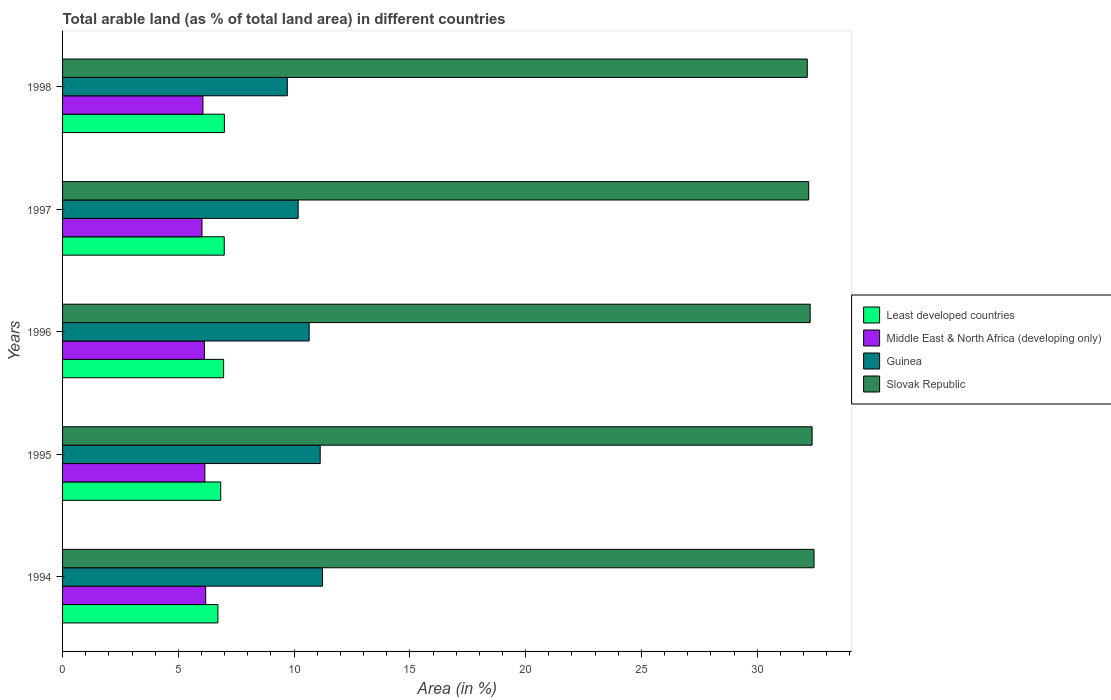How many different coloured bars are there?
Your answer should be compact. 4. Are the number of bars per tick equal to the number of legend labels?
Keep it short and to the point. Yes. How many bars are there on the 2nd tick from the top?
Offer a terse response. 4. How many bars are there on the 4th tick from the bottom?
Make the answer very short. 4. In how many cases, is the number of bars for a given year not equal to the number of legend labels?
Offer a terse response. 0. What is the percentage of arable land in Middle East & North Africa (developing only) in 1994?
Give a very brief answer. 6.18. Across all years, what is the maximum percentage of arable land in Slovak Republic?
Make the answer very short. 32.45. Across all years, what is the minimum percentage of arable land in Slovak Republic?
Ensure brevity in your answer.  32.16. What is the total percentage of arable land in Slovak Republic in the graph?
Offer a terse response. 161.5. What is the difference between the percentage of arable land in Slovak Republic in 1996 and that in 1998?
Keep it short and to the point. 0.12. What is the difference between the percentage of arable land in Least developed countries in 1994 and the percentage of arable land in Slovak Republic in 1998?
Offer a terse response. -25.45. What is the average percentage of arable land in Least developed countries per year?
Provide a succinct answer. 6.89. In the year 1997, what is the difference between the percentage of arable land in Guinea and percentage of arable land in Slovak Republic?
Offer a very short reply. -22.05. What is the ratio of the percentage of arable land in Guinea in 1996 to that in 1997?
Provide a short and direct response. 1.05. What is the difference between the highest and the second highest percentage of arable land in Least developed countries?
Provide a short and direct response. 0.01. What is the difference between the highest and the lowest percentage of arable land in Guinea?
Ensure brevity in your answer.  1.52. In how many years, is the percentage of arable land in Guinea greater than the average percentage of arable land in Guinea taken over all years?
Offer a very short reply. 3. What does the 3rd bar from the top in 1995 represents?
Provide a short and direct response. Middle East & North Africa (developing only). What does the 2nd bar from the bottom in 1996 represents?
Your answer should be very brief. Middle East & North Africa (developing only). How many bars are there?
Keep it short and to the point. 20. Does the graph contain any zero values?
Provide a succinct answer. No. Where does the legend appear in the graph?
Your answer should be compact. Center right. What is the title of the graph?
Offer a very short reply. Total arable land (as % of total land area) in different countries. Does "Sudan" appear as one of the legend labels in the graph?
Your answer should be compact. No. What is the label or title of the X-axis?
Offer a terse response. Area (in %). What is the Area (in %) of Least developed countries in 1994?
Give a very brief answer. 6.71. What is the Area (in %) of Middle East & North Africa (developing only) in 1994?
Provide a succinct answer. 6.18. What is the Area (in %) in Guinea in 1994?
Your response must be concise. 11.22. What is the Area (in %) of Slovak Republic in 1994?
Provide a short and direct response. 32.45. What is the Area (in %) of Least developed countries in 1995?
Offer a very short reply. 6.83. What is the Area (in %) of Middle East & North Africa (developing only) in 1995?
Give a very brief answer. 6.15. What is the Area (in %) of Guinea in 1995?
Provide a succinct answer. 11.13. What is the Area (in %) of Slovak Republic in 1995?
Offer a terse response. 32.37. What is the Area (in %) in Least developed countries in 1996?
Offer a terse response. 6.96. What is the Area (in %) of Middle East & North Africa (developing only) in 1996?
Your answer should be very brief. 6.13. What is the Area (in %) of Guinea in 1996?
Give a very brief answer. 10.65. What is the Area (in %) of Slovak Republic in 1996?
Offer a terse response. 32.29. What is the Area (in %) of Least developed countries in 1997?
Make the answer very short. 6.98. What is the Area (in %) of Middle East & North Africa (developing only) in 1997?
Provide a short and direct response. 6.02. What is the Area (in %) of Guinea in 1997?
Ensure brevity in your answer.  10.17. What is the Area (in %) of Slovak Republic in 1997?
Offer a terse response. 32.22. What is the Area (in %) in Least developed countries in 1998?
Your answer should be very brief. 6.99. What is the Area (in %) in Middle East & North Africa (developing only) in 1998?
Offer a very short reply. 6.06. What is the Area (in %) in Guinea in 1998?
Offer a very short reply. 9.71. What is the Area (in %) of Slovak Republic in 1998?
Your response must be concise. 32.16. Across all years, what is the maximum Area (in %) of Least developed countries?
Keep it short and to the point. 6.99. Across all years, what is the maximum Area (in %) of Middle East & North Africa (developing only)?
Your response must be concise. 6.18. Across all years, what is the maximum Area (in %) of Guinea?
Your answer should be very brief. 11.22. Across all years, what is the maximum Area (in %) in Slovak Republic?
Your response must be concise. 32.45. Across all years, what is the minimum Area (in %) of Least developed countries?
Ensure brevity in your answer.  6.71. Across all years, what is the minimum Area (in %) of Middle East & North Africa (developing only)?
Ensure brevity in your answer.  6.02. Across all years, what is the minimum Area (in %) in Guinea?
Offer a very short reply. 9.71. Across all years, what is the minimum Area (in %) of Slovak Republic?
Ensure brevity in your answer.  32.16. What is the total Area (in %) in Least developed countries in the graph?
Provide a short and direct response. 34.46. What is the total Area (in %) in Middle East & North Africa (developing only) in the graph?
Provide a succinct answer. 30.54. What is the total Area (in %) in Guinea in the graph?
Your answer should be compact. 52.88. What is the total Area (in %) of Slovak Republic in the graph?
Provide a short and direct response. 161.5. What is the difference between the Area (in %) in Least developed countries in 1994 and that in 1995?
Your answer should be very brief. -0.12. What is the difference between the Area (in %) in Middle East & North Africa (developing only) in 1994 and that in 1995?
Your answer should be very brief. 0.03. What is the difference between the Area (in %) in Guinea in 1994 and that in 1995?
Your response must be concise. 0.1. What is the difference between the Area (in %) of Slovak Republic in 1994 and that in 1995?
Give a very brief answer. 0.08. What is the difference between the Area (in %) in Least developed countries in 1994 and that in 1996?
Your answer should be very brief. -0.25. What is the difference between the Area (in %) of Middle East & North Africa (developing only) in 1994 and that in 1996?
Your answer should be very brief. 0.05. What is the difference between the Area (in %) of Guinea in 1994 and that in 1996?
Provide a succinct answer. 0.57. What is the difference between the Area (in %) in Slovak Republic in 1994 and that in 1996?
Provide a succinct answer. 0.17. What is the difference between the Area (in %) of Least developed countries in 1994 and that in 1997?
Your answer should be very brief. -0.27. What is the difference between the Area (in %) in Middle East & North Africa (developing only) in 1994 and that in 1997?
Your answer should be very brief. 0.16. What is the difference between the Area (in %) of Slovak Republic in 1994 and that in 1997?
Give a very brief answer. 0.23. What is the difference between the Area (in %) in Least developed countries in 1994 and that in 1998?
Provide a short and direct response. -0.28. What is the difference between the Area (in %) of Middle East & North Africa (developing only) in 1994 and that in 1998?
Offer a terse response. 0.12. What is the difference between the Area (in %) in Guinea in 1994 and that in 1998?
Keep it short and to the point. 1.52. What is the difference between the Area (in %) of Slovak Republic in 1994 and that in 1998?
Make the answer very short. 0.29. What is the difference between the Area (in %) of Least developed countries in 1995 and that in 1996?
Your response must be concise. -0.13. What is the difference between the Area (in %) of Middle East & North Africa (developing only) in 1995 and that in 1996?
Make the answer very short. 0.02. What is the difference between the Area (in %) in Guinea in 1995 and that in 1996?
Provide a short and direct response. 0.48. What is the difference between the Area (in %) of Slovak Republic in 1995 and that in 1996?
Your response must be concise. 0.08. What is the difference between the Area (in %) in Least developed countries in 1995 and that in 1997?
Your answer should be very brief. -0.15. What is the difference between the Area (in %) in Middle East & North Africa (developing only) in 1995 and that in 1997?
Keep it short and to the point. 0.13. What is the difference between the Area (in %) in Guinea in 1995 and that in 1997?
Provide a short and direct response. 0.95. What is the difference between the Area (in %) of Slovak Republic in 1995 and that in 1997?
Ensure brevity in your answer.  0.15. What is the difference between the Area (in %) of Least developed countries in 1995 and that in 1998?
Give a very brief answer. -0.16. What is the difference between the Area (in %) of Middle East & North Africa (developing only) in 1995 and that in 1998?
Make the answer very short. 0.08. What is the difference between the Area (in %) in Guinea in 1995 and that in 1998?
Keep it short and to the point. 1.42. What is the difference between the Area (in %) of Slovak Republic in 1995 and that in 1998?
Your response must be concise. 0.21. What is the difference between the Area (in %) in Least developed countries in 1996 and that in 1997?
Give a very brief answer. -0.03. What is the difference between the Area (in %) in Middle East & North Africa (developing only) in 1996 and that in 1997?
Give a very brief answer. 0.11. What is the difference between the Area (in %) of Guinea in 1996 and that in 1997?
Offer a very short reply. 0.48. What is the difference between the Area (in %) of Slovak Republic in 1996 and that in 1997?
Ensure brevity in your answer.  0.06. What is the difference between the Area (in %) of Least developed countries in 1996 and that in 1998?
Ensure brevity in your answer.  -0.03. What is the difference between the Area (in %) of Middle East & North Africa (developing only) in 1996 and that in 1998?
Provide a short and direct response. 0.06. What is the difference between the Area (in %) of Guinea in 1996 and that in 1998?
Offer a terse response. 0.94. What is the difference between the Area (in %) in Slovak Republic in 1996 and that in 1998?
Keep it short and to the point. 0.12. What is the difference between the Area (in %) in Least developed countries in 1997 and that in 1998?
Keep it short and to the point. -0.01. What is the difference between the Area (in %) in Middle East & North Africa (developing only) in 1997 and that in 1998?
Give a very brief answer. -0.04. What is the difference between the Area (in %) of Guinea in 1997 and that in 1998?
Offer a very short reply. 0.47. What is the difference between the Area (in %) in Slovak Republic in 1997 and that in 1998?
Your response must be concise. 0.06. What is the difference between the Area (in %) of Least developed countries in 1994 and the Area (in %) of Middle East & North Africa (developing only) in 1995?
Provide a succinct answer. 0.56. What is the difference between the Area (in %) in Least developed countries in 1994 and the Area (in %) in Guinea in 1995?
Ensure brevity in your answer.  -4.42. What is the difference between the Area (in %) in Least developed countries in 1994 and the Area (in %) in Slovak Republic in 1995?
Make the answer very short. -25.66. What is the difference between the Area (in %) of Middle East & North Africa (developing only) in 1994 and the Area (in %) of Guinea in 1995?
Your answer should be very brief. -4.95. What is the difference between the Area (in %) of Middle East & North Africa (developing only) in 1994 and the Area (in %) of Slovak Republic in 1995?
Offer a terse response. -26.19. What is the difference between the Area (in %) of Guinea in 1994 and the Area (in %) of Slovak Republic in 1995?
Provide a succinct answer. -21.15. What is the difference between the Area (in %) in Least developed countries in 1994 and the Area (in %) in Middle East & North Africa (developing only) in 1996?
Offer a terse response. 0.58. What is the difference between the Area (in %) in Least developed countries in 1994 and the Area (in %) in Guinea in 1996?
Offer a terse response. -3.94. What is the difference between the Area (in %) in Least developed countries in 1994 and the Area (in %) in Slovak Republic in 1996?
Offer a very short reply. -25.58. What is the difference between the Area (in %) in Middle East & North Africa (developing only) in 1994 and the Area (in %) in Guinea in 1996?
Your answer should be compact. -4.47. What is the difference between the Area (in %) in Middle East & North Africa (developing only) in 1994 and the Area (in %) in Slovak Republic in 1996?
Make the answer very short. -26.11. What is the difference between the Area (in %) of Guinea in 1994 and the Area (in %) of Slovak Republic in 1996?
Offer a terse response. -21.06. What is the difference between the Area (in %) in Least developed countries in 1994 and the Area (in %) in Middle East & North Africa (developing only) in 1997?
Your response must be concise. 0.69. What is the difference between the Area (in %) in Least developed countries in 1994 and the Area (in %) in Guinea in 1997?
Make the answer very short. -3.47. What is the difference between the Area (in %) of Least developed countries in 1994 and the Area (in %) of Slovak Republic in 1997?
Offer a very short reply. -25.52. What is the difference between the Area (in %) in Middle East & North Africa (developing only) in 1994 and the Area (in %) in Guinea in 1997?
Make the answer very short. -3.99. What is the difference between the Area (in %) of Middle East & North Africa (developing only) in 1994 and the Area (in %) of Slovak Republic in 1997?
Ensure brevity in your answer.  -26.04. What is the difference between the Area (in %) in Guinea in 1994 and the Area (in %) in Slovak Republic in 1997?
Your response must be concise. -21. What is the difference between the Area (in %) of Least developed countries in 1994 and the Area (in %) of Middle East & North Africa (developing only) in 1998?
Provide a short and direct response. 0.65. What is the difference between the Area (in %) in Least developed countries in 1994 and the Area (in %) in Guinea in 1998?
Your response must be concise. -3. What is the difference between the Area (in %) in Least developed countries in 1994 and the Area (in %) in Slovak Republic in 1998?
Ensure brevity in your answer.  -25.45. What is the difference between the Area (in %) of Middle East & North Africa (developing only) in 1994 and the Area (in %) of Guinea in 1998?
Your answer should be compact. -3.53. What is the difference between the Area (in %) in Middle East & North Africa (developing only) in 1994 and the Area (in %) in Slovak Republic in 1998?
Offer a terse response. -25.98. What is the difference between the Area (in %) in Guinea in 1994 and the Area (in %) in Slovak Republic in 1998?
Offer a very short reply. -20.94. What is the difference between the Area (in %) in Least developed countries in 1995 and the Area (in %) in Middle East & North Africa (developing only) in 1996?
Offer a terse response. 0.7. What is the difference between the Area (in %) of Least developed countries in 1995 and the Area (in %) of Guinea in 1996?
Keep it short and to the point. -3.82. What is the difference between the Area (in %) of Least developed countries in 1995 and the Area (in %) of Slovak Republic in 1996?
Keep it short and to the point. -25.46. What is the difference between the Area (in %) of Middle East & North Africa (developing only) in 1995 and the Area (in %) of Guinea in 1996?
Ensure brevity in your answer.  -4.5. What is the difference between the Area (in %) of Middle East & North Africa (developing only) in 1995 and the Area (in %) of Slovak Republic in 1996?
Offer a very short reply. -26.14. What is the difference between the Area (in %) in Guinea in 1995 and the Area (in %) in Slovak Republic in 1996?
Ensure brevity in your answer.  -21.16. What is the difference between the Area (in %) in Least developed countries in 1995 and the Area (in %) in Middle East & North Africa (developing only) in 1997?
Offer a very short reply. 0.81. What is the difference between the Area (in %) of Least developed countries in 1995 and the Area (in %) of Guinea in 1997?
Keep it short and to the point. -3.35. What is the difference between the Area (in %) in Least developed countries in 1995 and the Area (in %) in Slovak Republic in 1997?
Ensure brevity in your answer.  -25.4. What is the difference between the Area (in %) in Middle East & North Africa (developing only) in 1995 and the Area (in %) in Guinea in 1997?
Make the answer very short. -4.03. What is the difference between the Area (in %) of Middle East & North Africa (developing only) in 1995 and the Area (in %) of Slovak Republic in 1997?
Make the answer very short. -26.08. What is the difference between the Area (in %) in Guinea in 1995 and the Area (in %) in Slovak Republic in 1997?
Offer a very short reply. -21.1. What is the difference between the Area (in %) in Least developed countries in 1995 and the Area (in %) in Middle East & North Africa (developing only) in 1998?
Provide a succinct answer. 0.77. What is the difference between the Area (in %) in Least developed countries in 1995 and the Area (in %) in Guinea in 1998?
Your response must be concise. -2.88. What is the difference between the Area (in %) in Least developed countries in 1995 and the Area (in %) in Slovak Republic in 1998?
Give a very brief answer. -25.33. What is the difference between the Area (in %) of Middle East & North Africa (developing only) in 1995 and the Area (in %) of Guinea in 1998?
Provide a succinct answer. -3.56. What is the difference between the Area (in %) of Middle East & North Africa (developing only) in 1995 and the Area (in %) of Slovak Republic in 1998?
Ensure brevity in your answer.  -26.02. What is the difference between the Area (in %) of Guinea in 1995 and the Area (in %) of Slovak Republic in 1998?
Offer a very short reply. -21.04. What is the difference between the Area (in %) in Least developed countries in 1996 and the Area (in %) in Middle East & North Africa (developing only) in 1997?
Your response must be concise. 0.94. What is the difference between the Area (in %) of Least developed countries in 1996 and the Area (in %) of Guinea in 1997?
Offer a terse response. -3.22. What is the difference between the Area (in %) of Least developed countries in 1996 and the Area (in %) of Slovak Republic in 1997?
Your answer should be compact. -25.27. What is the difference between the Area (in %) in Middle East & North Africa (developing only) in 1996 and the Area (in %) in Guinea in 1997?
Make the answer very short. -4.05. What is the difference between the Area (in %) in Middle East & North Africa (developing only) in 1996 and the Area (in %) in Slovak Republic in 1997?
Provide a short and direct response. -26.1. What is the difference between the Area (in %) of Guinea in 1996 and the Area (in %) of Slovak Republic in 1997?
Offer a terse response. -21.57. What is the difference between the Area (in %) of Least developed countries in 1996 and the Area (in %) of Middle East & North Africa (developing only) in 1998?
Ensure brevity in your answer.  0.89. What is the difference between the Area (in %) of Least developed countries in 1996 and the Area (in %) of Guinea in 1998?
Provide a succinct answer. -2.75. What is the difference between the Area (in %) in Least developed countries in 1996 and the Area (in %) in Slovak Republic in 1998?
Your answer should be very brief. -25.21. What is the difference between the Area (in %) in Middle East & North Africa (developing only) in 1996 and the Area (in %) in Guinea in 1998?
Offer a terse response. -3.58. What is the difference between the Area (in %) in Middle East & North Africa (developing only) in 1996 and the Area (in %) in Slovak Republic in 1998?
Your answer should be very brief. -26.04. What is the difference between the Area (in %) of Guinea in 1996 and the Area (in %) of Slovak Republic in 1998?
Keep it short and to the point. -21.51. What is the difference between the Area (in %) of Least developed countries in 1997 and the Area (in %) of Middle East & North Africa (developing only) in 1998?
Provide a succinct answer. 0.92. What is the difference between the Area (in %) of Least developed countries in 1997 and the Area (in %) of Guinea in 1998?
Your answer should be compact. -2.72. What is the difference between the Area (in %) of Least developed countries in 1997 and the Area (in %) of Slovak Republic in 1998?
Offer a very short reply. -25.18. What is the difference between the Area (in %) in Middle East & North Africa (developing only) in 1997 and the Area (in %) in Guinea in 1998?
Your answer should be compact. -3.69. What is the difference between the Area (in %) in Middle East & North Africa (developing only) in 1997 and the Area (in %) in Slovak Republic in 1998?
Make the answer very short. -26.14. What is the difference between the Area (in %) of Guinea in 1997 and the Area (in %) of Slovak Republic in 1998?
Your response must be concise. -21.99. What is the average Area (in %) of Least developed countries per year?
Offer a very short reply. 6.89. What is the average Area (in %) in Middle East & North Africa (developing only) per year?
Provide a succinct answer. 6.11. What is the average Area (in %) of Guinea per year?
Your answer should be compact. 10.58. What is the average Area (in %) in Slovak Republic per year?
Offer a terse response. 32.3. In the year 1994, what is the difference between the Area (in %) of Least developed countries and Area (in %) of Middle East & North Africa (developing only)?
Provide a short and direct response. 0.53. In the year 1994, what is the difference between the Area (in %) of Least developed countries and Area (in %) of Guinea?
Your response must be concise. -4.52. In the year 1994, what is the difference between the Area (in %) of Least developed countries and Area (in %) of Slovak Republic?
Provide a succinct answer. -25.74. In the year 1994, what is the difference between the Area (in %) in Middle East & North Africa (developing only) and Area (in %) in Guinea?
Your answer should be compact. -5.04. In the year 1994, what is the difference between the Area (in %) in Middle East & North Africa (developing only) and Area (in %) in Slovak Republic?
Give a very brief answer. -26.27. In the year 1994, what is the difference between the Area (in %) of Guinea and Area (in %) of Slovak Republic?
Make the answer very short. -21.23. In the year 1995, what is the difference between the Area (in %) in Least developed countries and Area (in %) in Middle East & North Africa (developing only)?
Make the answer very short. 0.68. In the year 1995, what is the difference between the Area (in %) in Least developed countries and Area (in %) in Guinea?
Your answer should be very brief. -4.3. In the year 1995, what is the difference between the Area (in %) in Least developed countries and Area (in %) in Slovak Republic?
Provide a short and direct response. -25.54. In the year 1995, what is the difference between the Area (in %) of Middle East & North Africa (developing only) and Area (in %) of Guinea?
Give a very brief answer. -4.98. In the year 1995, what is the difference between the Area (in %) of Middle East & North Africa (developing only) and Area (in %) of Slovak Republic?
Ensure brevity in your answer.  -26.22. In the year 1995, what is the difference between the Area (in %) of Guinea and Area (in %) of Slovak Republic?
Provide a succinct answer. -21.24. In the year 1996, what is the difference between the Area (in %) of Least developed countries and Area (in %) of Middle East & North Africa (developing only)?
Provide a succinct answer. 0.83. In the year 1996, what is the difference between the Area (in %) in Least developed countries and Area (in %) in Guinea?
Offer a very short reply. -3.69. In the year 1996, what is the difference between the Area (in %) in Least developed countries and Area (in %) in Slovak Republic?
Your response must be concise. -25.33. In the year 1996, what is the difference between the Area (in %) of Middle East & North Africa (developing only) and Area (in %) of Guinea?
Offer a terse response. -4.52. In the year 1996, what is the difference between the Area (in %) in Middle East & North Africa (developing only) and Area (in %) in Slovak Republic?
Ensure brevity in your answer.  -26.16. In the year 1996, what is the difference between the Area (in %) in Guinea and Area (in %) in Slovak Republic?
Your answer should be compact. -21.64. In the year 1997, what is the difference between the Area (in %) in Least developed countries and Area (in %) in Middle East & North Africa (developing only)?
Your answer should be compact. 0.96. In the year 1997, what is the difference between the Area (in %) of Least developed countries and Area (in %) of Guinea?
Offer a terse response. -3.19. In the year 1997, what is the difference between the Area (in %) in Least developed countries and Area (in %) in Slovak Republic?
Provide a succinct answer. -25.24. In the year 1997, what is the difference between the Area (in %) in Middle East & North Africa (developing only) and Area (in %) in Guinea?
Give a very brief answer. -4.15. In the year 1997, what is the difference between the Area (in %) in Middle East & North Africa (developing only) and Area (in %) in Slovak Republic?
Your answer should be compact. -26.2. In the year 1997, what is the difference between the Area (in %) of Guinea and Area (in %) of Slovak Republic?
Your response must be concise. -22.05. In the year 1998, what is the difference between the Area (in %) in Least developed countries and Area (in %) in Middle East & North Africa (developing only)?
Keep it short and to the point. 0.93. In the year 1998, what is the difference between the Area (in %) in Least developed countries and Area (in %) in Guinea?
Offer a terse response. -2.72. In the year 1998, what is the difference between the Area (in %) of Least developed countries and Area (in %) of Slovak Republic?
Give a very brief answer. -25.17. In the year 1998, what is the difference between the Area (in %) of Middle East & North Africa (developing only) and Area (in %) of Guinea?
Your answer should be very brief. -3.64. In the year 1998, what is the difference between the Area (in %) in Middle East & North Africa (developing only) and Area (in %) in Slovak Republic?
Make the answer very short. -26.1. In the year 1998, what is the difference between the Area (in %) of Guinea and Area (in %) of Slovak Republic?
Give a very brief answer. -22.46. What is the ratio of the Area (in %) in Least developed countries in 1994 to that in 1995?
Keep it short and to the point. 0.98. What is the ratio of the Area (in %) in Middle East & North Africa (developing only) in 1994 to that in 1995?
Your answer should be very brief. 1.01. What is the ratio of the Area (in %) in Guinea in 1994 to that in 1995?
Provide a short and direct response. 1.01. What is the ratio of the Area (in %) in Slovak Republic in 1994 to that in 1995?
Keep it short and to the point. 1. What is the ratio of the Area (in %) of Least developed countries in 1994 to that in 1996?
Your answer should be very brief. 0.96. What is the ratio of the Area (in %) in Middle East & North Africa (developing only) in 1994 to that in 1996?
Your answer should be compact. 1.01. What is the ratio of the Area (in %) of Guinea in 1994 to that in 1996?
Make the answer very short. 1.05. What is the ratio of the Area (in %) in Least developed countries in 1994 to that in 1997?
Your answer should be very brief. 0.96. What is the ratio of the Area (in %) in Middle East & North Africa (developing only) in 1994 to that in 1997?
Keep it short and to the point. 1.03. What is the ratio of the Area (in %) of Guinea in 1994 to that in 1997?
Give a very brief answer. 1.1. What is the ratio of the Area (in %) in Slovak Republic in 1994 to that in 1997?
Offer a terse response. 1.01. What is the ratio of the Area (in %) in Least developed countries in 1994 to that in 1998?
Offer a terse response. 0.96. What is the ratio of the Area (in %) of Middle East & North Africa (developing only) in 1994 to that in 1998?
Give a very brief answer. 1.02. What is the ratio of the Area (in %) in Guinea in 1994 to that in 1998?
Your response must be concise. 1.16. What is the ratio of the Area (in %) in Slovak Republic in 1994 to that in 1998?
Your response must be concise. 1.01. What is the ratio of the Area (in %) of Least developed countries in 1995 to that in 1996?
Provide a short and direct response. 0.98. What is the ratio of the Area (in %) of Middle East & North Africa (developing only) in 1995 to that in 1996?
Your answer should be very brief. 1. What is the ratio of the Area (in %) in Guinea in 1995 to that in 1996?
Your answer should be compact. 1.04. What is the ratio of the Area (in %) in Slovak Republic in 1995 to that in 1996?
Offer a terse response. 1. What is the ratio of the Area (in %) in Least developed countries in 1995 to that in 1997?
Your answer should be compact. 0.98. What is the ratio of the Area (in %) of Guinea in 1995 to that in 1997?
Provide a short and direct response. 1.09. What is the ratio of the Area (in %) in Least developed countries in 1995 to that in 1998?
Offer a very short reply. 0.98. What is the ratio of the Area (in %) in Middle East & North Africa (developing only) in 1995 to that in 1998?
Provide a short and direct response. 1.01. What is the ratio of the Area (in %) in Guinea in 1995 to that in 1998?
Your answer should be compact. 1.15. What is the ratio of the Area (in %) of Least developed countries in 1996 to that in 1997?
Ensure brevity in your answer.  1. What is the ratio of the Area (in %) of Middle East & North Africa (developing only) in 1996 to that in 1997?
Give a very brief answer. 1.02. What is the ratio of the Area (in %) of Guinea in 1996 to that in 1997?
Keep it short and to the point. 1.05. What is the ratio of the Area (in %) of Slovak Republic in 1996 to that in 1997?
Your answer should be very brief. 1. What is the ratio of the Area (in %) of Least developed countries in 1996 to that in 1998?
Keep it short and to the point. 1. What is the ratio of the Area (in %) of Middle East & North Africa (developing only) in 1996 to that in 1998?
Your answer should be very brief. 1.01. What is the ratio of the Area (in %) of Guinea in 1996 to that in 1998?
Offer a very short reply. 1.1. What is the ratio of the Area (in %) in Least developed countries in 1997 to that in 1998?
Keep it short and to the point. 1. What is the ratio of the Area (in %) of Middle East & North Africa (developing only) in 1997 to that in 1998?
Offer a terse response. 0.99. What is the ratio of the Area (in %) in Guinea in 1997 to that in 1998?
Ensure brevity in your answer.  1.05. What is the ratio of the Area (in %) in Slovak Republic in 1997 to that in 1998?
Your answer should be compact. 1. What is the difference between the highest and the second highest Area (in %) in Least developed countries?
Provide a short and direct response. 0.01. What is the difference between the highest and the second highest Area (in %) in Middle East & North Africa (developing only)?
Offer a very short reply. 0.03. What is the difference between the highest and the second highest Area (in %) in Guinea?
Your response must be concise. 0.1. What is the difference between the highest and the second highest Area (in %) in Slovak Republic?
Give a very brief answer. 0.08. What is the difference between the highest and the lowest Area (in %) of Least developed countries?
Give a very brief answer. 0.28. What is the difference between the highest and the lowest Area (in %) in Middle East & North Africa (developing only)?
Provide a succinct answer. 0.16. What is the difference between the highest and the lowest Area (in %) of Guinea?
Your answer should be compact. 1.52. What is the difference between the highest and the lowest Area (in %) of Slovak Republic?
Ensure brevity in your answer.  0.29. 